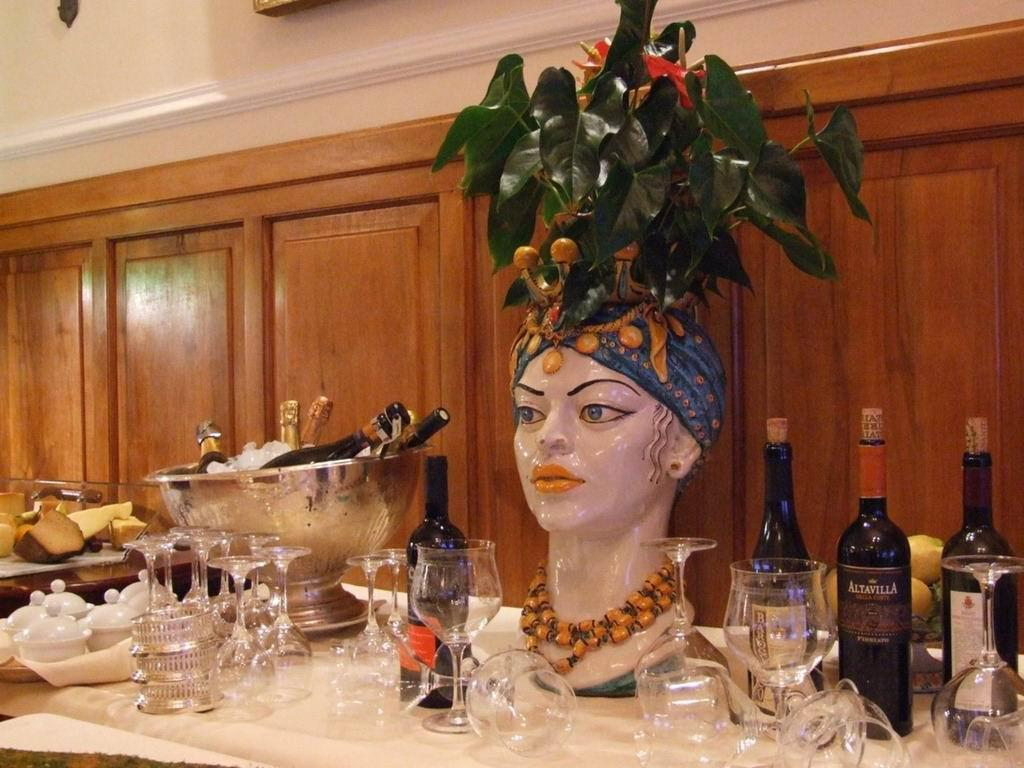What is the main piece of furniture in the image? There is a table in the image. What is placed on the table? A statue, glasses, a bowl, wine bottles, and fruit are present on the table. What can be seen in the background of the image? There is a wall and a door in the background of the image. What type of cracker is being used as a caption for the image? There is no cracker present in the image, nor is there any caption. 